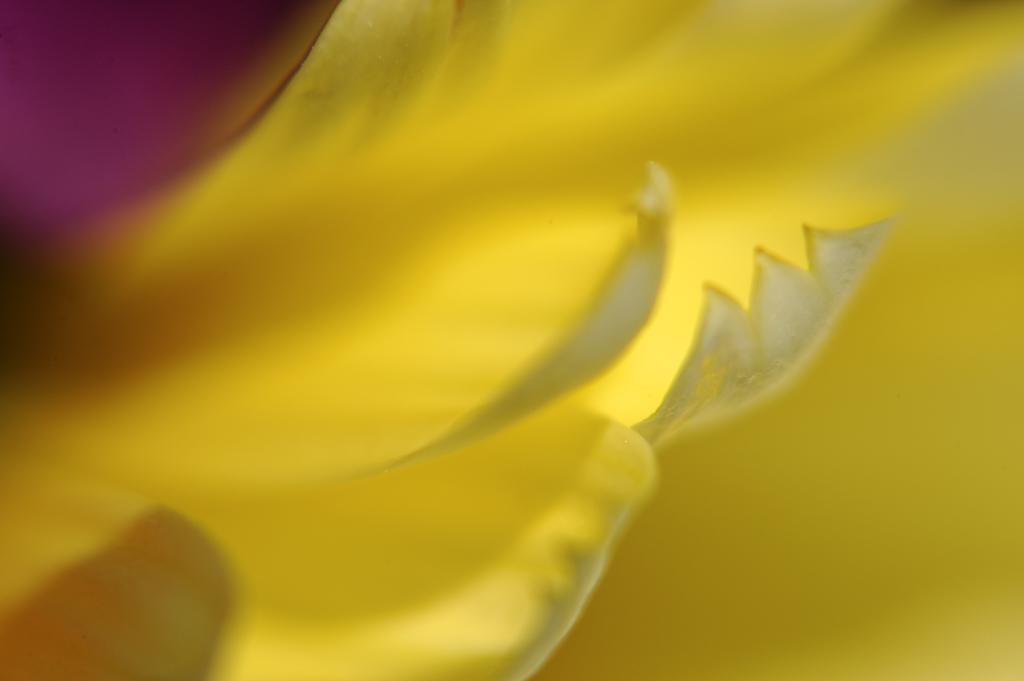Please provide a concise description of this image. In this picture the image is not clear but we can see objects. 